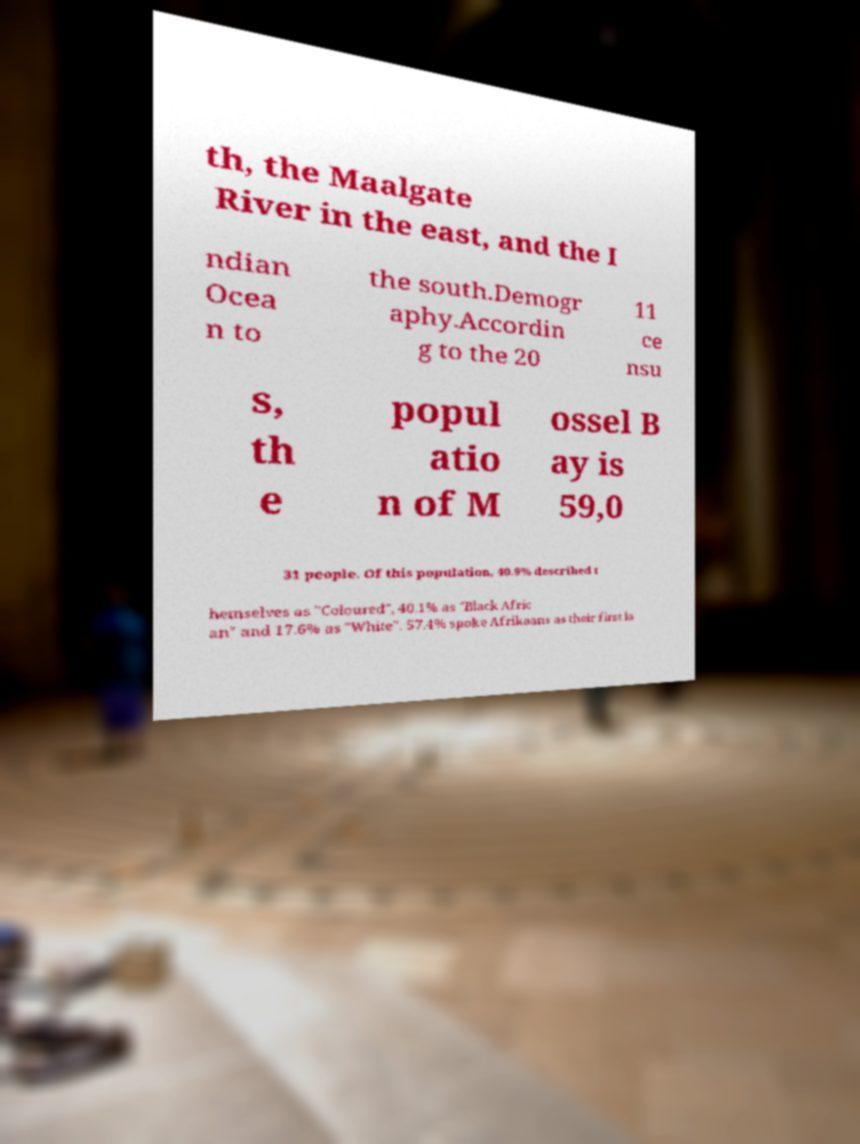What messages or text are displayed in this image? I need them in a readable, typed format. th, the Maalgate River in the east, and the I ndian Ocea n to the south.Demogr aphy.Accordin g to the 20 11 ce nsu s, th e popul atio n of M ossel B ay is 59,0 31 people. Of this population, 40.9% described t hemselves as "Coloured", 40.1% as "Black Afric an" and 17.6% as "White". 57.4% spoke Afrikaans as their first la 